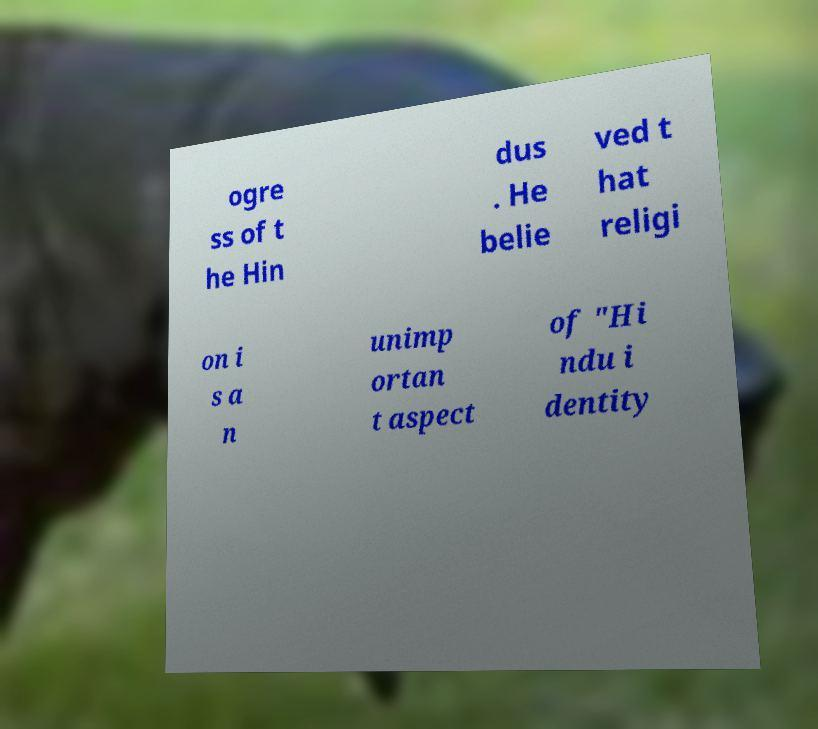Can you accurately transcribe the text from the provided image for me? ogre ss of t he Hin dus . He belie ved t hat religi on i s a n unimp ortan t aspect of "Hi ndu i dentity 